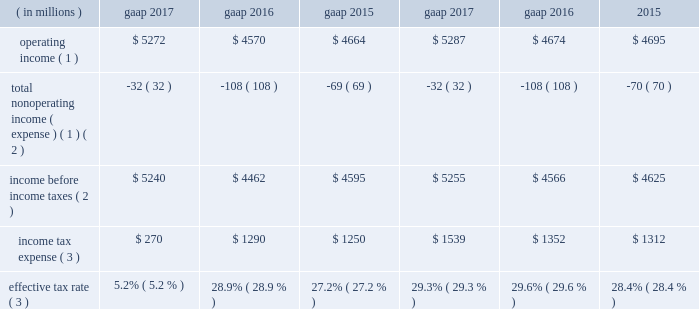Income tax expense .
Operating income ( 1 ) $ 5272 $ 4570 $ 4664 $ 5287 $ 4674 $ 4695 total nonoperating income ( expense ) ( 1 ) ( 2 ) ( 32 ) ( 108 ) ( 69 ) ( 32 ) ( 108 ) ( 70 ) income before income taxes ( 2 ) $ 5240 $ 4462 $ 4595 $ 5255 $ 4566 $ 4625 income tax expense ( 3 ) $ 270 $ 1290 $ 1250 $ 1539 $ 1352 $ 1312 effective tax rate ( 3 ) 5.2% ( 5.2 % ) 28.9% ( 28.9 % ) 27.2% ( 27.2 % ) 29.3% ( 29.3 % ) 29.6% ( 29.6 % ) 28.4% ( 28.4 % ) ( 1 ) see non-gaap financial measures for further information on and reconciliation of as adjusted items .
( 2 ) net of net income ( loss ) attributable to nci .
( 3 ) gaap income tax expense and effective tax rate for 2017 reflects $ 1.2 billion of a net tax benefit related to the 2017 tax act .
The company 2019s tax rate is affected by tax rates in foreign jurisdictions and the relative amount of income earned in those jurisdictions , which the company expects to be fairly consistent in the near term .
The significant foreign jurisdictions that have lower statutory tax rates than the u.s .
Federal statutory rate of 35% ( 35 % ) include the united kingdom , channel islands , ireland and netherlands .
2017 .
Income tax expense ( gaap ) reflected : 2022 the following amounts related to the 2017 tax act : 2022 $ 106 million tax expense related to the revaluation of certain deferred income tax assets ; 2022 $ 1758 million noncash tax benefit related to the revaluation of certain deferred income tax liabilities ; 2022 $ 477 million tax expense related to the mandatory deemed repatriation of undistributed foreign earnings and profits .
2022 a noncash expense of $ 16 million , primarily associated with the revaluation of certain deferred income tax liabilities as a result of domestic state and local tax changes ; and 2022 $ 173 million discrete tax benefits , primarily related to stock-based compensation awards , including $ 151 million related to the adoption of new accounting guidance related to stock-based compensation awards .
See note 2 , significant accounting policies , for further information .
The as adjusted effective tax rate of 29.3% ( 29.3 % ) for 2017 excluded the noncash deferred tax revaluation benefit of $ 1758 million and noncash expense of $ 16 million mentioned above as it will not have a cash flow impact and to ensure comparability among periods presented .
In addition , the deemed repatriation tax expense of $ 477 million has been excluded from the as adjusted results due to the one-time nature and to ensure comparability among periods presented .
2016 .
Income tax expense ( gaap ) reflected : 2022 a net noncash benefit of $ 30 million , primarily associated with the revaluation of certain deferred income tax liabilities ; and 2022 a benefit from $ 65 million of nonrecurring items , including the resolution of certain outstanding tax matters .
The as adjusted effective tax rate of 29.6% ( 29.6 % ) for 2016 excluded the net noncash benefit of $ 30 million mentioned above as it will not have a cash flow impact and to ensure comparability among periods presented .
2015 .
Income tax expense ( gaap ) reflected : 2022 a net noncash benefit of $ 54 million , primarily associated with the revaluation of certain deferred income tax liabilities ; and 2022 a benefit from $ 75 million of nonrecurring items , primarily due to the realization of losses from changes in the company 2019s organizational tax structure and the resolution of certain outstanding tax matters .
The as adjusted effective tax rate of 28.4% ( 28.4 % ) for 2015 excluded the net noncash benefit of $ 54 million mentioned above , as it will not have a cash flow impact and to ensure comparability among periods presented .
Balance sheet overview as adjusted balance sheet the following table presents a reconciliation of the consolidated statement of financial condition presented on a gaap basis to the consolidated statement of financial condition , excluding the impact of separate account assets and separate account collateral held under securities lending agreements ( directly related to lending separate account securities ) and separate account liabilities and separate account collateral liabilities under securities lending agreements and consolidated sponsored investment funds , including consolidated vies .
The company presents the as adjusted balance sheet as additional information to enable investors to exclude certain assets that have equal and offsetting liabilities or noncontrolling interests that ultimately do not have an impact on stockholders 2019 equity or cash flows .
Management views the as adjusted balance sheet , which contains non-gaap financial measures , as an economic presentation of the company 2019s total assets and liabilities ; however , it does not advocate that investors consider such non-gaap financial measures in isolation from , or as a substitute for , financial information prepared in accordance with gaap .
Separate account assets and liabilities and separate account collateral held under securities lending agreements separate account assets are maintained by blackrock life limited , a wholly owned subsidiary of the company that is a registered life insurance company in the united kingdom , and represent segregated assets held for purposes of funding individual and group pension contracts .
The .
What is the growth rate in operating income from 2016 to 2017? 
Computations: ((5272 - 4570) / 4570)
Answer: 0.15361. 